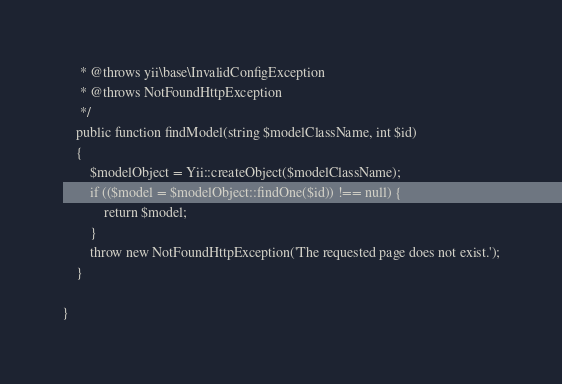Convert code to text. <code><loc_0><loc_0><loc_500><loc_500><_PHP_>     * @throws yii\base\InvalidConfigException
     * @throws NotFoundHttpException
     */
    public function findModel(string $modelClassName, int $id)
    {
        $modelObject = Yii::createObject($modelClassName);
        if (($model = $modelObject::findOne($id)) !== null) {
            return $model;
        }
        throw new NotFoundHttpException('The requested page does not exist.');
    }

}</code> 